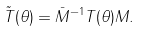Convert formula to latex. <formula><loc_0><loc_0><loc_500><loc_500>\tilde { T } ( \theta ) = \bar { M } ^ { - 1 } T ( \theta ) M .</formula> 